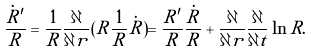<formula> <loc_0><loc_0><loc_500><loc_500>\frac { \dot { R } ^ { \prime } } { R } = \frac { 1 } { R } \frac { \partial } { \partial r } ( R \frac { 1 } { R } \dot { R } ) = \frac { R ^ { \prime } } { R } \frac { \dot { R } } { R } + \frac { \partial } { \partial r } \frac { \partial } { \partial t } \ln R .</formula> 